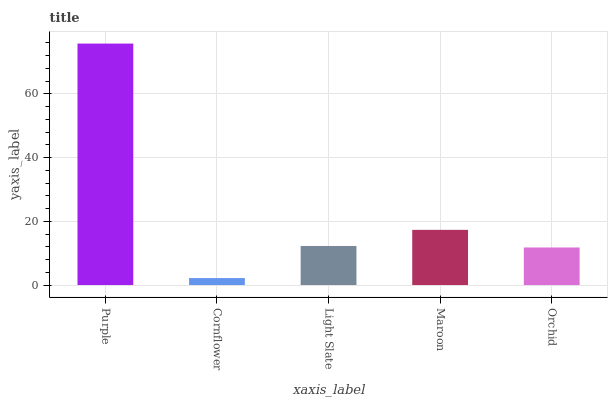Is Cornflower the minimum?
Answer yes or no. Yes. Is Purple the maximum?
Answer yes or no. Yes. Is Light Slate the minimum?
Answer yes or no. No. Is Light Slate the maximum?
Answer yes or no. No. Is Light Slate greater than Cornflower?
Answer yes or no. Yes. Is Cornflower less than Light Slate?
Answer yes or no. Yes. Is Cornflower greater than Light Slate?
Answer yes or no. No. Is Light Slate less than Cornflower?
Answer yes or no. No. Is Light Slate the high median?
Answer yes or no. Yes. Is Light Slate the low median?
Answer yes or no. Yes. Is Orchid the high median?
Answer yes or no. No. Is Maroon the low median?
Answer yes or no. No. 